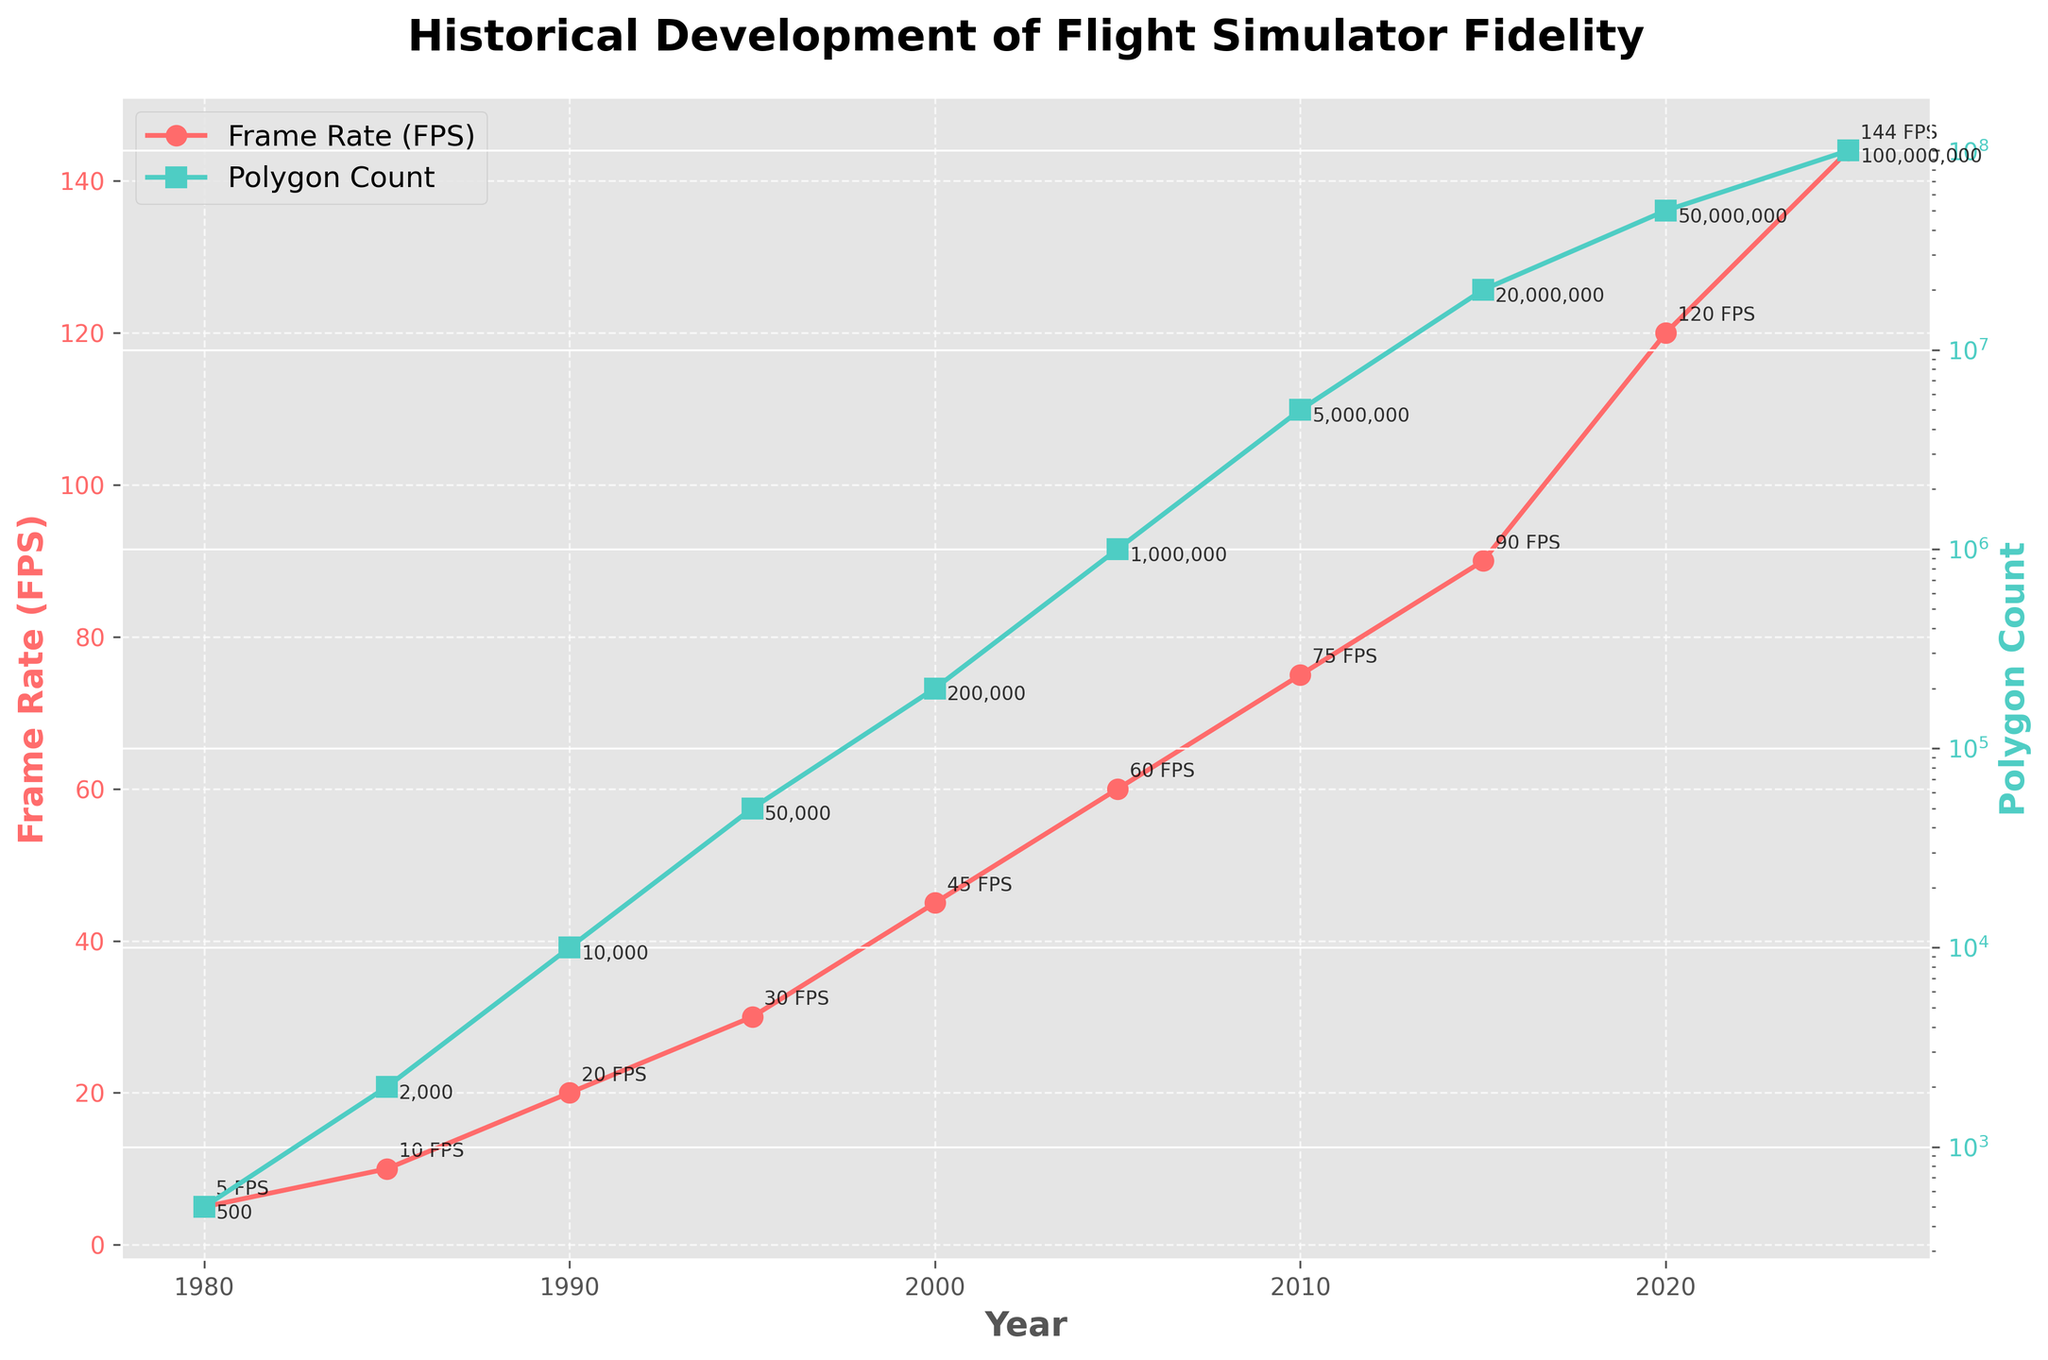What year did the frame rate reach 60 FPS for the first time? The frame rate data shows it reached 60 FPS in the year 2005.
Answer: 2005 How many times larger is the polygon count in 2025 compared to 1980? The polygon count in 2025 is 100,000,000 and in 1980 it is 500. Dividing the two gives 100,000,000 / 500 = 200,000 times larger.
Answer: 200,000 What is the difference in frame rate between 1995 and 2005? The frame rate in 1995 is 30 FPS and in 2005 it is 60 FPS. The difference is 60 - 30 = 30 FPS.
Answer: 30 FPS Which parameter, frame rate or polygon count, has grown faster between 1980 and 2025? The frame rate increased from 5 FPS to 144 FPS, and the polygon count increased from 500 to 100,000,000. The polygon count shows a much larger growth rate.
Answer: Polygon count What's the average frame rate for the years 2000 to 2020? The frame rates are 45, 60, 75, 90, and 120 for the years 2000, 2005, 2010, 2015, and 2020 respectively. The sum is 45 + 60 + 75 + 90 + 120 = 390. There are 5 data points, so the average is 390 / 5 = 78 FPS.
Answer: 78 FPS In which year did the polygon count first exceed 1,000,000? The polygon count exceeded 1,000,000 for the first time in 2005.
Answer: 2005 By how much did the polygon count increase from the year 2000 to 2005? The polygon count in 2000 was 200,000 and in 2005 it was 1,000,000. The increase is 1,000,000 - 200,000 = 800,000.
Answer: 800,000 Which color represents the frame rate in the plot? The frame rate is represented by the red line with circle markers.
Answer: Red Is the increase in frame rate consistent over the years, and how can you tell? The increase in frame rate starts slow and accelerates over time, noticeable by the steeper slope in the latter years.
Answer: No Are there any years where both the frame rate and polygon count increase simultaneously? Yes, in every period shown (e.g., 2000 to 2005, 2010 to 2015), both frame rate and polygon count increase simultaneously, evident from both lines trending upwards.
Answer: Yes 